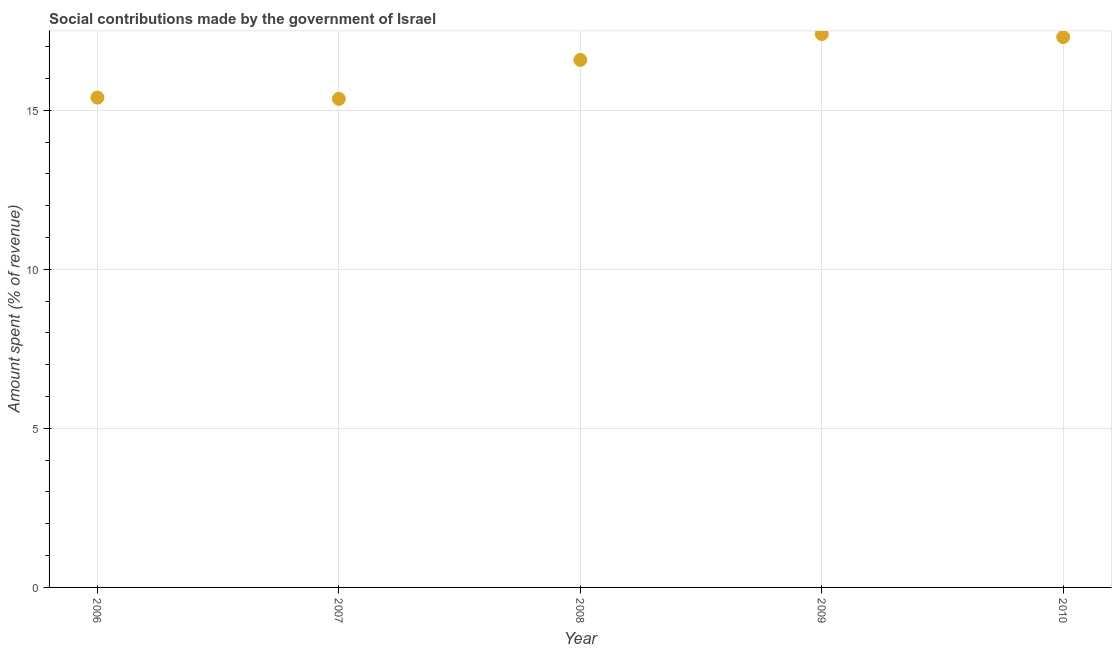What is the amount spent in making social contributions in 2010?
Provide a succinct answer. 17.3. Across all years, what is the maximum amount spent in making social contributions?
Ensure brevity in your answer.  17.4. Across all years, what is the minimum amount spent in making social contributions?
Keep it short and to the point. 15.36. What is the sum of the amount spent in making social contributions?
Offer a terse response. 82.03. What is the difference between the amount spent in making social contributions in 2007 and 2008?
Your answer should be compact. -1.22. What is the average amount spent in making social contributions per year?
Provide a succinct answer. 16.41. What is the median amount spent in making social contributions?
Your response must be concise. 16.58. In how many years, is the amount spent in making social contributions greater than 6 %?
Keep it short and to the point. 5. Do a majority of the years between 2006 and 2010 (inclusive) have amount spent in making social contributions greater than 12 %?
Provide a short and direct response. Yes. What is the ratio of the amount spent in making social contributions in 2007 to that in 2008?
Offer a very short reply. 0.93. Is the amount spent in making social contributions in 2007 less than that in 2010?
Offer a terse response. Yes. What is the difference between the highest and the second highest amount spent in making social contributions?
Give a very brief answer. 0.1. Is the sum of the amount spent in making social contributions in 2006 and 2008 greater than the maximum amount spent in making social contributions across all years?
Keep it short and to the point. Yes. What is the difference between the highest and the lowest amount spent in making social contributions?
Ensure brevity in your answer.  2.04. How many years are there in the graph?
Provide a short and direct response. 5. What is the difference between two consecutive major ticks on the Y-axis?
Offer a terse response. 5. Are the values on the major ticks of Y-axis written in scientific E-notation?
Your answer should be very brief. No. Does the graph contain any zero values?
Keep it short and to the point. No. Does the graph contain grids?
Your response must be concise. Yes. What is the title of the graph?
Your response must be concise. Social contributions made by the government of Israel. What is the label or title of the X-axis?
Offer a very short reply. Year. What is the label or title of the Y-axis?
Ensure brevity in your answer.  Amount spent (% of revenue). What is the Amount spent (% of revenue) in 2006?
Make the answer very short. 15.4. What is the Amount spent (% of revenue) in 2007?
Offer a terse response. 15.36. What is the Amount spent (% of revenue) in 2008?
Offer a terse response. 16.58. What is the Amount spent (% of revenue) in 2009?
Give a very brief answer. 17.4. What is the Amount spent (% of revenue) in 2010?
Offer a terse response. 17.3. What is the difference between the Amount spent (% of revenue) in 2006 and 2007?
Give a very brief answer. 0.04. What is the difference between the Amount spent (% of revenue) in 2006 and 2008?
Keep it short and to the point. -1.18. What is the difference between the Amount spent (% of revenue) in 2006 and 2009?
Keep it short and to the point. -2. What is the difference between the Amount spent (% of revenue) in 2006 and 2010?
Provide a short and direct response. -1.9. What is the difference between the Amount spent (% of revenue) in 2007 and 2008?
Offer a very short reply. -1.22. What is the difference between the Amount spent (% of revenue) in 2007 and 2009?
Offer a terse response. -2.04. What is the difference between the Amount spent (% of revenue) in 2007 and 2010?
Make the answer very short. -1.94. What is the difference between the Amount spent (% of revenue) in 2008 and 2009?
Your answer should be very brief. -0.81. What is the difference between the Amount spent (% of revenue) in 2008 and 2010?
Ensure brevity in your answer.  -0.72. What is the difference between the Amount spent (% of revenue) in 2009 and 2010?
Keep it short and to the point. 0.1. What is the ratio of the Amount spent (% of revenue) in 2006 to that in 2008?
Give a very brief answer. 0.93. What is the ratio of the Amount spent (% of revenue) in 2006 to that in 2009?
Your response must be concise. 0.89. What is the ratio of the Amount spent (% of revenue) in 2006 to that in 2010?
Your answer should be very brief. 0.89. What is the ratio of the Amount spent (% of revenue) in 2007 to that in 2008?
Provide a succinct answer. 0.93. What is the ratio of the Amount spent (% of revenue) in 2007 to that in 2009?
Keep it short and to the point. 0.88. What is the ratio of the Amount spent (% of revenue) in 2007 to that in 2010?
Give a very brief answer. 0.89. What is the ratio of the Amount spent (% of revenue) in 2008 to that in 2009?
Provide a succinct answer. 0.95. What is the ratio of the Amount spent (% of revenue) in 2009 to that in 2010?
Keep it short and to the point. 1.01. 